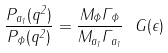Convert formula to latex. <formula><loc_0><loc_0><loc_500><loc_500>\frac { P _ { a _ { 1 } } ( q ^ { 2 } ) } { P _ { \Phi } ( q ^ { 2 } ) } = \frac { M _ { \Phi } \Gamma _ { \Phi } } { M _ { a _ { 1 } } \Gamma _ { a _ { 1 } } } \ G ( \epsilon )</formula> 